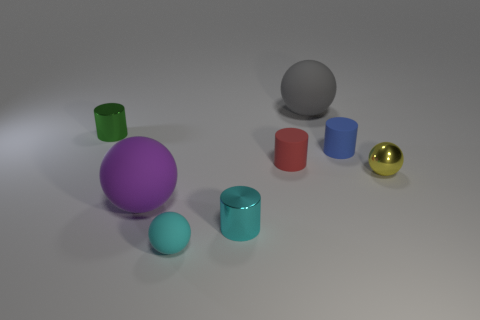Are there more tiny yellow shiny objects that are behind the tiny blue object than small red cylinders?
Your answer should be very brief. No. What is the color of the shiny cylinder to the right of the big rubber ball that is to the left of the tiny cyan metal cylinder?
Make the answer very short. Cyan. How many blue rubber blocks are there?
Ensure brevity in your answer.  0. What number of spheres are both in front of the tiny blue cylinder and on the left side of the blue matte thing?
Offer a terse response. 2. Is there anything else that is the same shape as the blue object?
Ensure brevity in your answer.  Yes. There is a metallic sphere; does it have the same color as the tiny cylinder that is behind the blue cylinder?
Provide a short and direct response. No. The gray rubber thing that is behind the red matte thing has what shape?
Make the answer very short. Sphere. What number of other things are there of the same material as the cyan cylinder
Your answer should be very brief. 2. What is the material of the small green object?
Your answer should be compact. Metal. What number of small objects are green cylinders or metallic cylinders?
Ensure brevity in your answer.  2. 